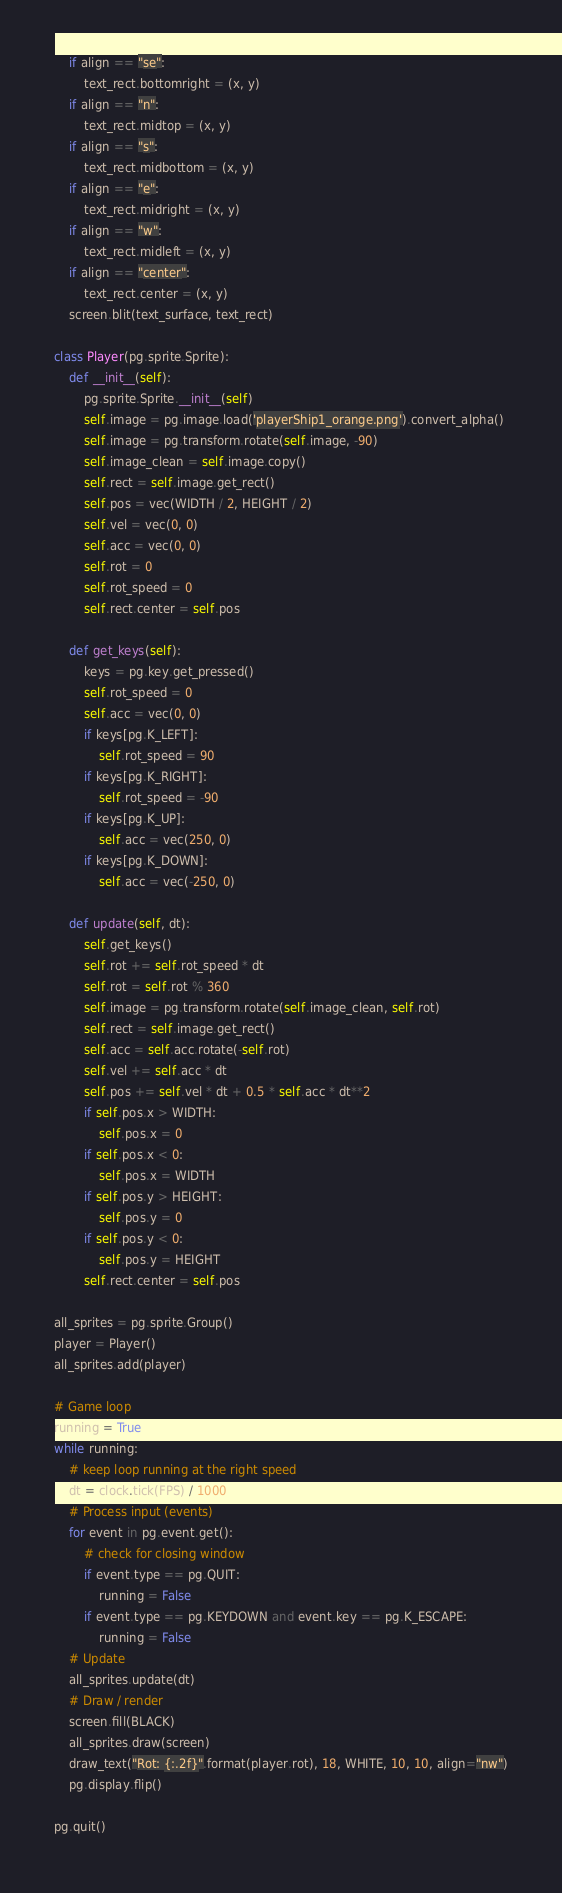Convert code to text. <code><loc_0><loc_0><loc_500><loc_500><_Python_>    if align == "se":
        text_rect.bottomright = (x, y)
    if align == "n":
        text_rect.midtop = (x, y)
    if align == "s":
        text_rect.midbottom = (x, y)
    if align == "e":
        text_rect.midright = (x, y)
    if align == "w":
        text_rect.midleft = (x, y)
    if align == "center":
        text_rect.center = (x, y)
    screen.blit(text_surface, text_rect)

class Player(pg.sprite.Sprite):
    def __init__(self):
        pg.sprite.Sprite.__init__(self)
        self.image = pg.image.load('playerShip1_orange.png').convert_alpha()
        self.image = pg.transform.rotate(self.image, -90)
        self.image_clean = self.image.copy()
        self.rect = self.image.get_rect()
        self.pos = vec(WIDTH / 2, HEIGHT / 2)
        self.vel = vec(0, 0)
        self.acc = vec(0, 0)
        self.rot = 0
        self.rot_speed = 0
        self.rect.center = self.pos

    def get_keys(self):
        keys = pg.key.get_pressed()
        self.rot_speed = 0
        self.acc = vec(0, 0)
        if keys[pg.K_LEFT]:
            self.rot_speed = 90
        if keys[pg.K_RIGHT]:
            self.rot_speed = -90
        if keys[pg.K_UP]:
            self.acc = vec(250, 0)
        if keys[pg.K_DOWN]:
            self.acc = vec(-250, 0)

    def update(self, dt):
        self.get_keys()
        self.rot += self.rot_speed * dt
        self.rot = self.rot % 360
        self.image = pg.transform.rotate(self.image_clean, self.rot)
        self.rect = self.image.get_rect()
        self.acc = self.acc.rotate(-self.rot)
        self.vel += self.acc * dt
        self.pos += self.vel * dt + 0.5 * self.acc * dt**2
        if self.pos.x > WIDTH:
            self.pos.x = 0
        if self.pos.x < 0:
            self.pos.x = WIDTH
        if self.pos.y > HEIGHT:
            self.pos.y = 0
        if self.pos.y < 0:
            self.pos.y = HEIGHT
        self.rect.center = self.pos

all_sprites = pg.sprite.Group()
player = Player()
all_sprites.add(player)

# Game loop
running = True
while running:
    # keep loop running at the right speed
    dt = clock.tick(FPS) / 1000
    # Process input (events)
    for event in pg.event.get():
        # check for closing window
        if event.type == pg.QUIT:
            running = False
        if event.type == pg.KEYDOWN and event.key == pg.K_ESCAPE:
            running = False
    # Update
    all_sprites.update(dt)
    # Draw / render
    screen.fill(BLACK)
    all_sprites.draw(screen)
    draw_text("Rot: {:.2f}".format(player.rot), 18, WHITE, 10, 10, align="nw")
    pg.display.flip()

pg.quit()
</code> 